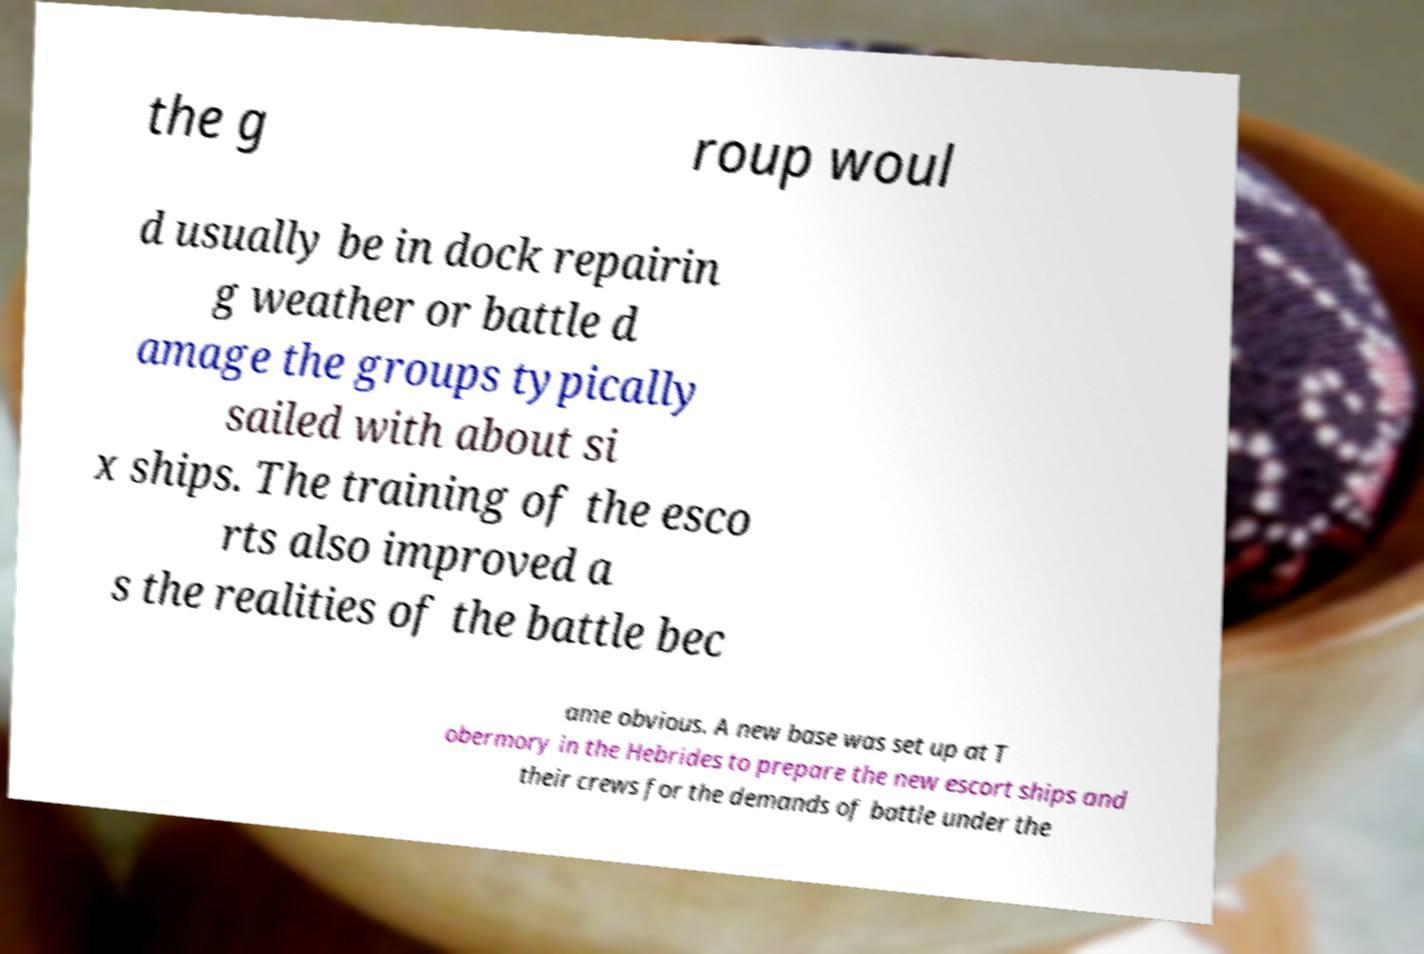Could you assist in decoding the text presented in this image and type it out clearly? the g roup woul d usually be in dock repairin g weather or battle d amage the groups typically sailed with about si x ships. The training of the esco rts also improved a s the realities of the battle bec ame obvious. A new base was set up at T obermory in the Hebrides to prepare the new escort ships and their crews for the demands of battle under the 